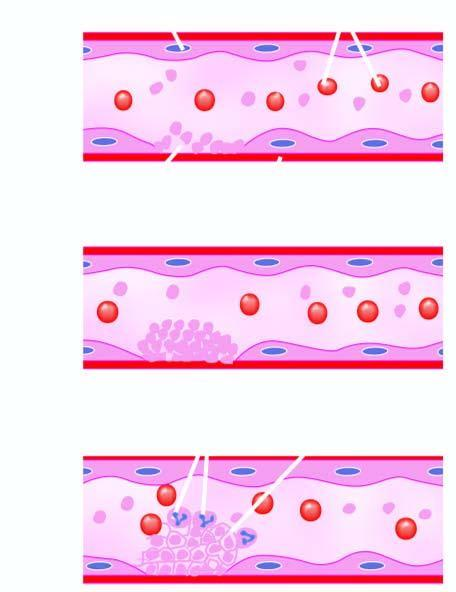s c, x-ray crystallography and infra-red spectroscopy formed called thrombus?
Answer the question using a single word or phrase. No 